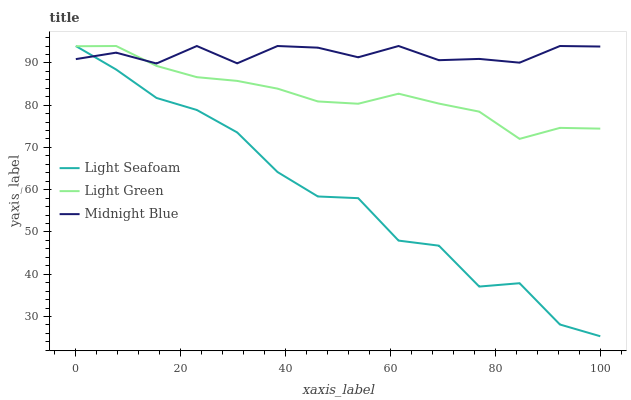Does Light Seafoam have the minimum area under the curve?
Answer yes or no. Yes. Does Midnight Blue have the maximum area under the curve?
Answer yes or no. Yes. Does Light Green have the minimum area under the curve?
Answer yes or no. No. Does Light Green have the maximum area under the curve?
Answer yes or no. No. Is Light Green the smoothest?
Answer yes or no. Yes. Is Light Seafoam the roughest?
Answer yes or no. Yes. Is Midnight Blue the smoothest?
Answer yes or no. No. Is Midnight Blue the roughest?
Answer yes or no. No. Does Light Green have the lowest value?
Answer yes or no. No. 